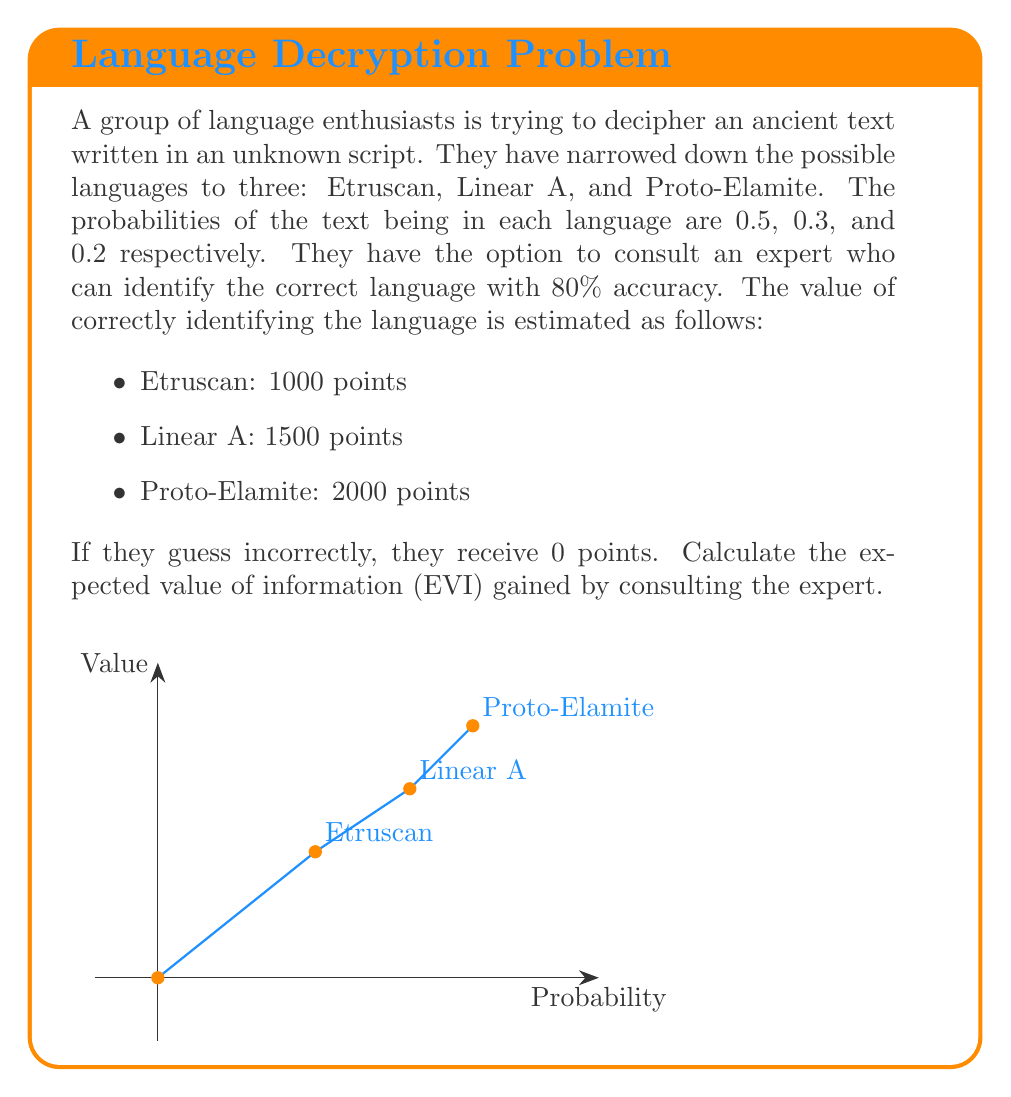Could you help me with this problem? To calculate the Expected Value of Information (EVI), we need to follow these steps:

1. Calculate the expected value without consulting the expert:
   Let $EV_0$ be this value.
   $$EV_0 = 0.5 \cdot 1000 + 0.3 \cdot 1500 + 0.2 \cdot 2000 = 1350$$

2. Calculate the expected value with expert consultation:
   Let $EV_1$ be this value.
   
   For each language, we need to consider:
   a) The probability of the expert correctly identifying it (0.8)
   b) The probability of the expert misidentifying it (0.2)

   For Etruscan:
   $$0.5 \cdot (0.8 \cdot 1000 + 0.2 \cdot 0) = 400$$
   
   For Linear A:
   $$0.3 \cdot (0.8 \cdot 1500 + 0.2 \cdot 0) = 360$$
   
   For Proto-Elamite:
   $$0.2 \cdot (0.8 \cdot 2000 + 0.2 \cdot 0) = 320$$

   $$EV_1 = 400 + 360 + 320 = 1080$$

3. Calculate the Expected Value of Information:
   $$EVI = EV_1 - EV_0 = 1080 - 1350 = -270$$

The negative EVI indicates that consulting the expert actually decreases the expected value. This is because the expert's accuracy (80%) is not high enough to compensate for the risk of misidentification, given the different values associated with each language.
Answer: $-270$ points 